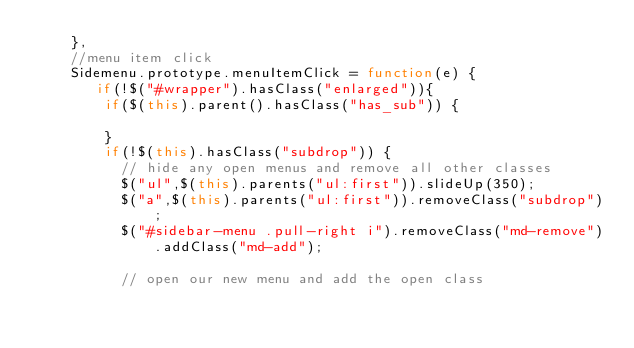<code> <loc_0><loc_0><loc_500><loc_500><_JavaScript_>    },
    //menu item click
    Sidemenu.prototype.menuItemClick = function(e) {
       if(!$("#wrapper").hasClass("enlarged")){
        if($(this).parent().hasClass("has_sub")) {

        }
        if(!$(this).hasClass("subdrop")) {
          // hide any open menus and remove all other classes
          $("ul",$(this).parents("ul:first")).slideUp(350);
          $("a",$(this).parents("ul:first")).removeClass("subdrop");
          $("#sidebar-menu .pull-right i").removeClass("md-remove").addClass("md-add");

          // open our new menu and add the open class</code> 